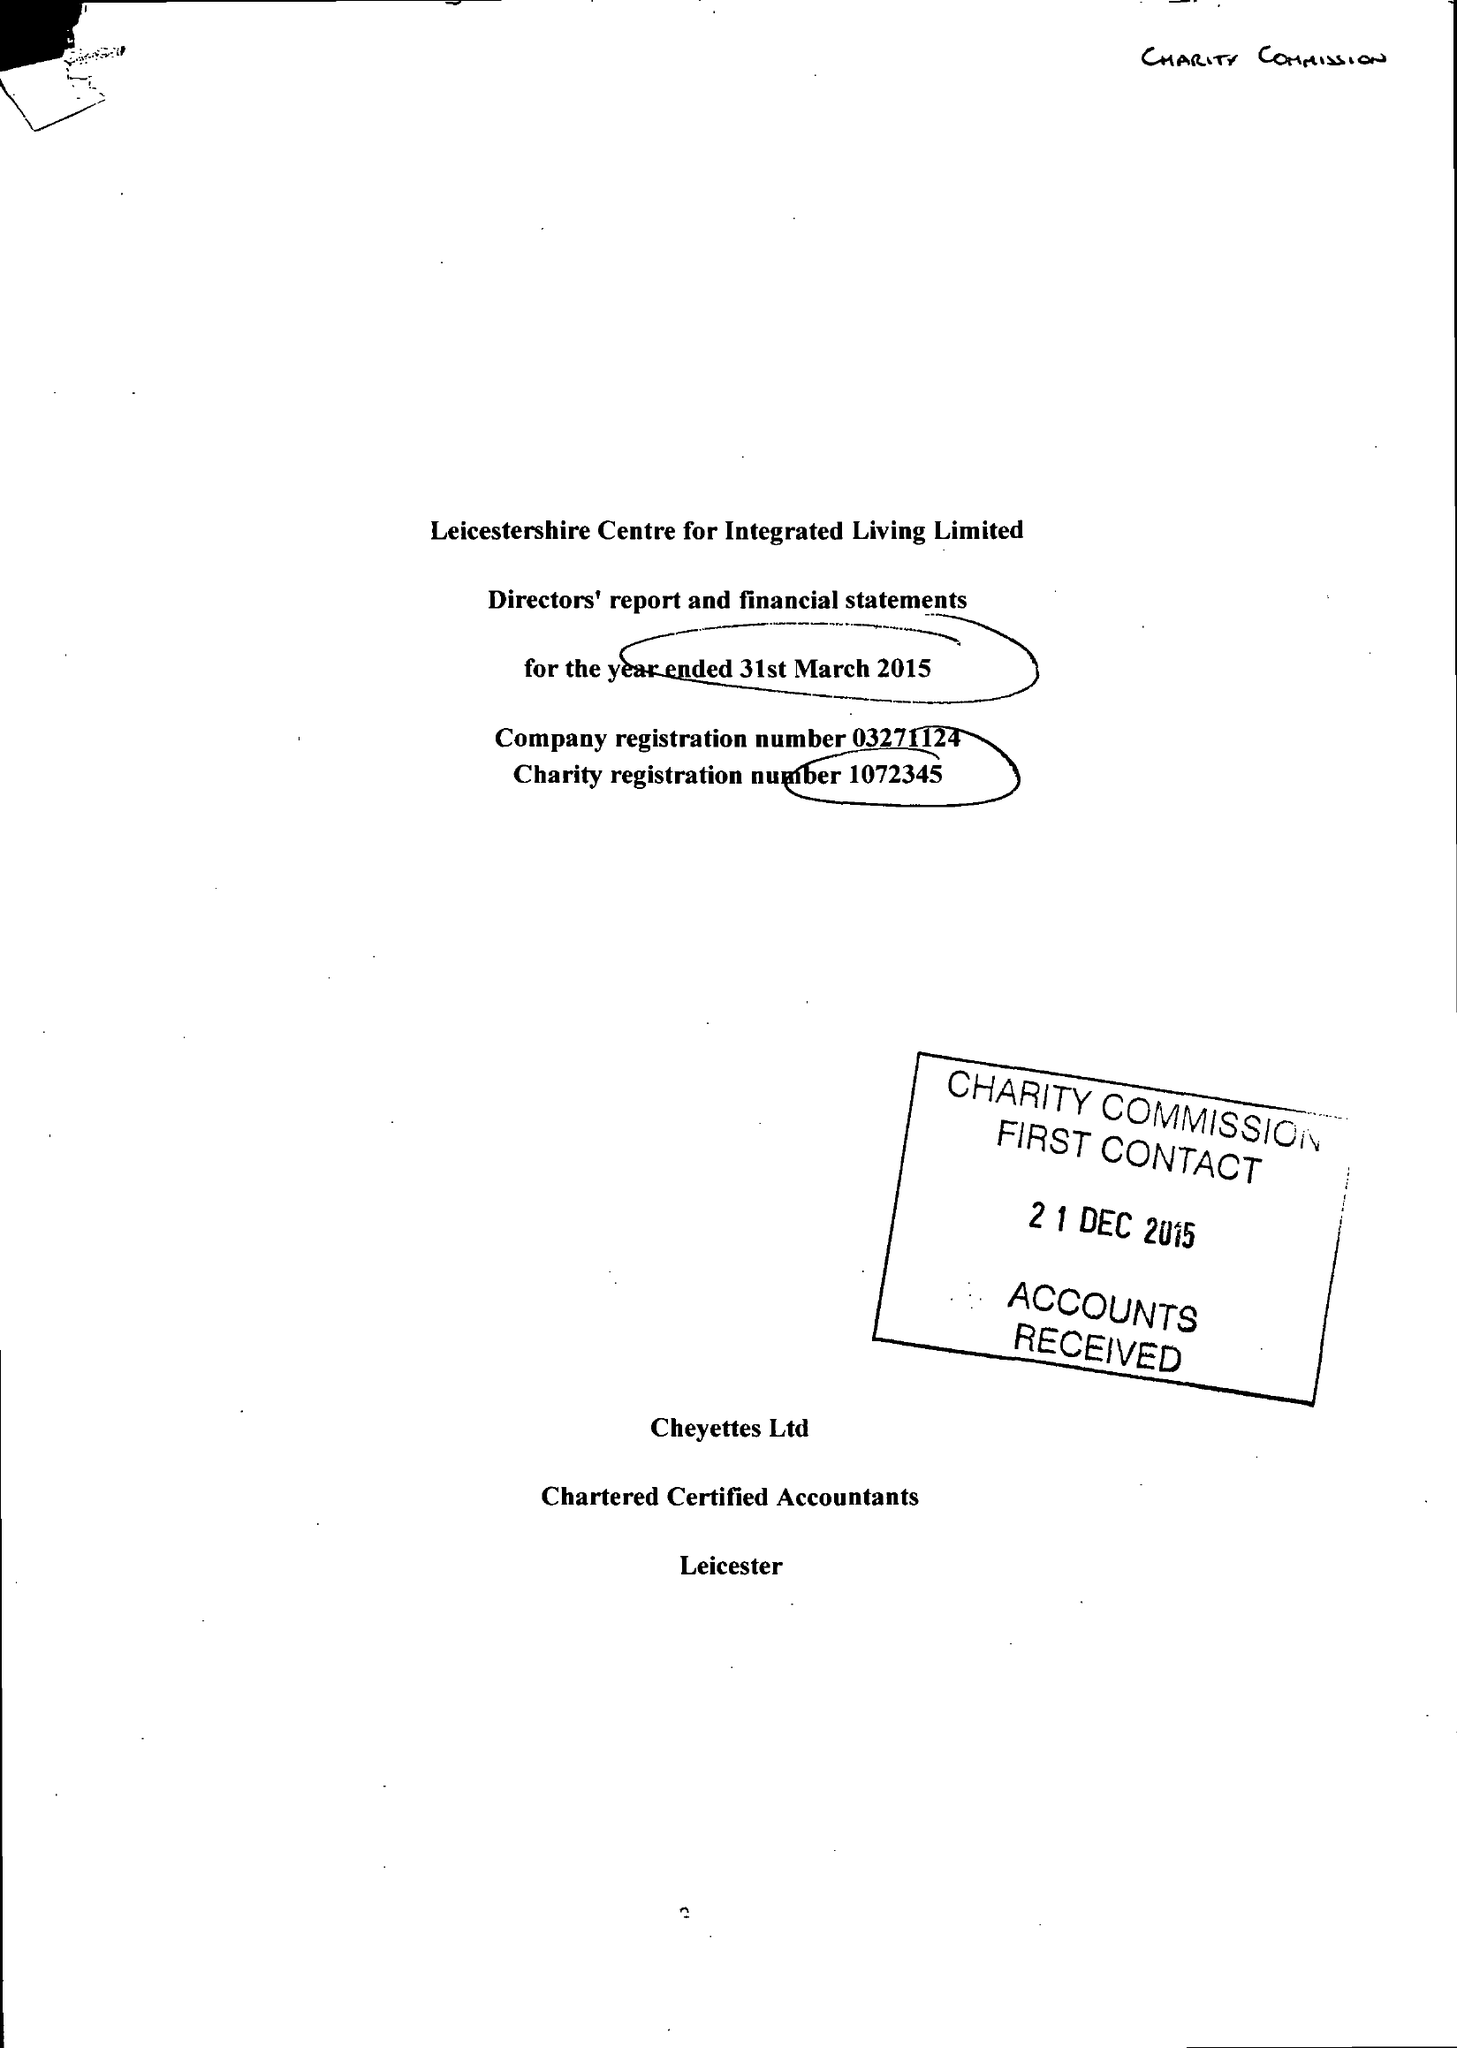What is the value for the charity_number?
Answer the question using a single word or phrase. 1072345 